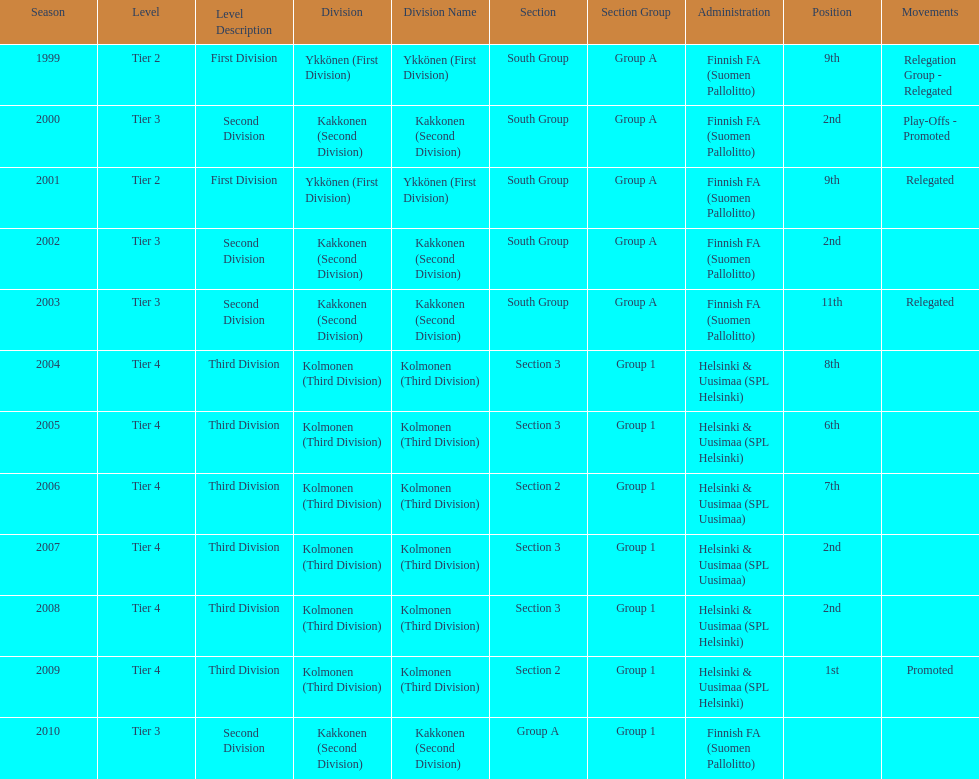How many tiers had more than one relegated movement? 1. 